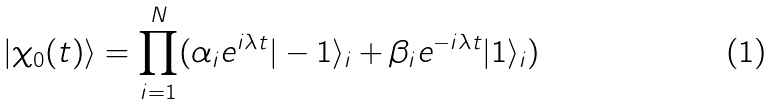<formula> <loc_0><loc_0><loc_500><loc_500>| \chi _ { 0 } ( t ) \rangle = \prod _ { i = 1 } ^ { N } ( \alpha _ { i } e ^ { i \lambda t } | - 1 \rangle _ { i } + \beta _ { i } e ^ { - i \lambda t } | 1 \rangle _ { i } )</formula> 